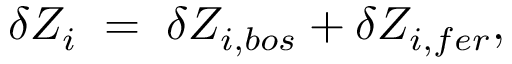<formula> <loc_0><loc_0><loc_500><loc_500>\delta Z _ { i } \, = \, \delta Z _ { i , b o s } + \delta Z _ { i , f e r } ,</formula> 